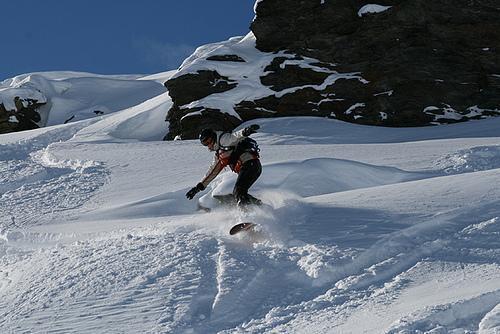How many black remotes are on the table?
Give a very brief answer. 0. 